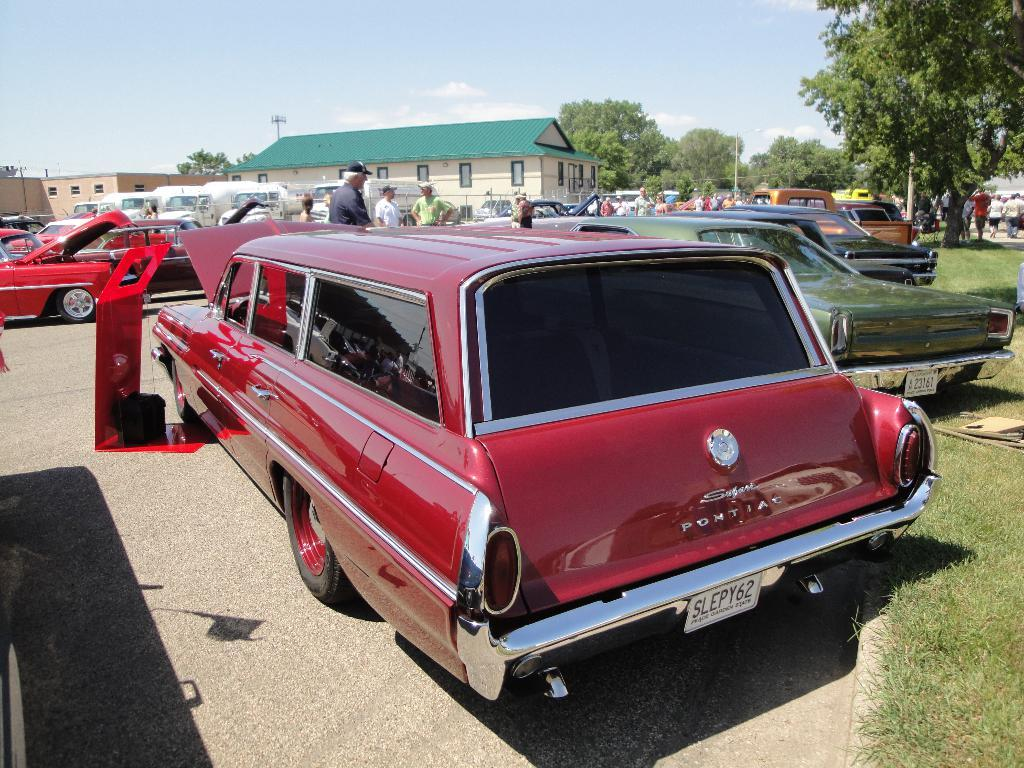What types of objects are present in the image? There are vehicles and people standing on the ground in the image. What can be seen in the background of the image? There are buildings, trees, grass, poles, and the sky visible in the background of the image. How many different types of objects are present in the background? There are at least six different types of objects present in the background: buildings, trees, grass, poles, other objects, and the sky. What is the weight of the stream in the image? There is no stream present in the image, so it is not possible to determine its weight. How does the neck of the person in the image look? There is no person's neck visible in the image, as the focus is on the vehicles and people standing on the ground. 